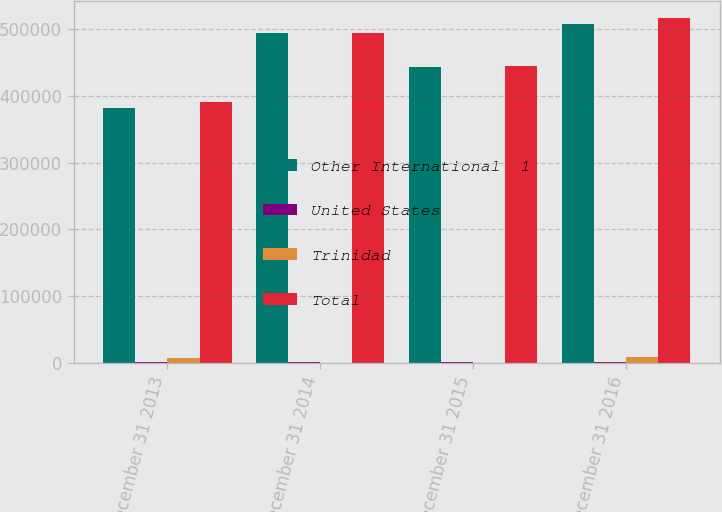Convert chart to OTSL. <chart><loc_0><loc_0><loc_500><loc_500><stacked_bar_chart><ecel><fcel>December 31 2013<fcel>December 31 2014<fcel>December 31 2015<fcel>December 31 2016<nl><fcel>Other International  1<fcel>382517<fcel>493694<fcel>444070<fcel>507531<nl><fcel>United States<fcel>1505<fcel>1339<fcel>1069<fcel>839<nl><fcel>Trinidad<fcel>7034<fcel>115<fcel>63<fcel>8255<nl><fcel>Total<fcel>391056<fcel>495148<fcel>445202<fcel>516625<nl></chart> 